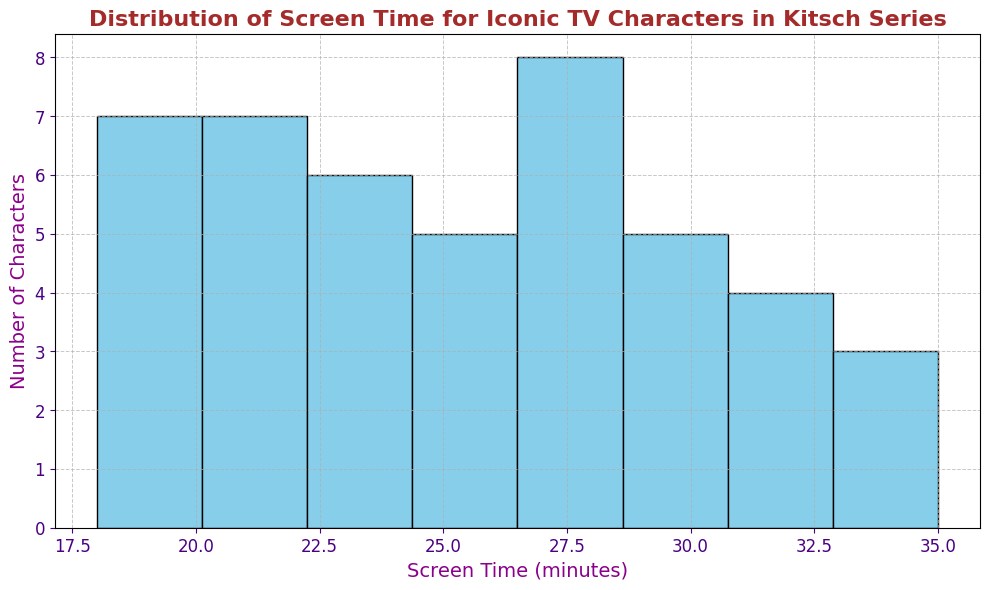What is the most common range of screen time for these iconic TV characters? Looking at the histogram, identify the range (bin) that has the highest bar, which indicates the most common range.
Answer: 24-27 minutes Which character has the highest screen time, and how long is it? Refer to the individual screen time values and visually identify the character with the bar extending the furthest to the right.
Answer: Frasier Crane, 35 minutes How many characters have a screen time of less than 20 minutes? Count the number of bars that fall into the bins representing less than 20 minutes of screen time.
Answer: 4 characters Are there more characters with screen times above 30 minutes or below 20 minutes? Compare the count of characters in the bins above 30 minutes with those in the bins below 20 minutes.
Answer: Above 30 minutes What is the average screen time of the characters shown in the histogram? Calculate the sum of all screen times and divide by the total number of characters.
Answer: 25.48 minutes Which range of screen time has the fewest characters, and how many characters are in that range? Identify the bin with the shortest bar on the histogram and count the number of characters in that bin.
Answer: 18-21 minutes, 6 characters How does the screen time of Maude Findlay compare with that of Carl Winslow? Find the screen time values of both characters and compare these values.
Answer: Maude Findlay has 27 minutes, and Carl Winslow has 26 minutes; Maude's screen time is 1 minute longer What is the total screen time for all the characters in the range of 27-30 minutes? Add the screen times of all characters that fall within the bin 27-30 minutes.
Answer: 172 minutes How many characters have a screen time between 20 and 25 minutes inclusive? Count the characters in the histogram bins that fall within the 20-25 minutes range.
Answer: 12 characters Is there a significant difference between the number of characters with screen times in the bins 24-27 minutes and 28-31 minutes? Compare the heights of the bars in these bins to check if there is a noticeable difference.
Answer: No significant difference, both have similar numbers of characters 